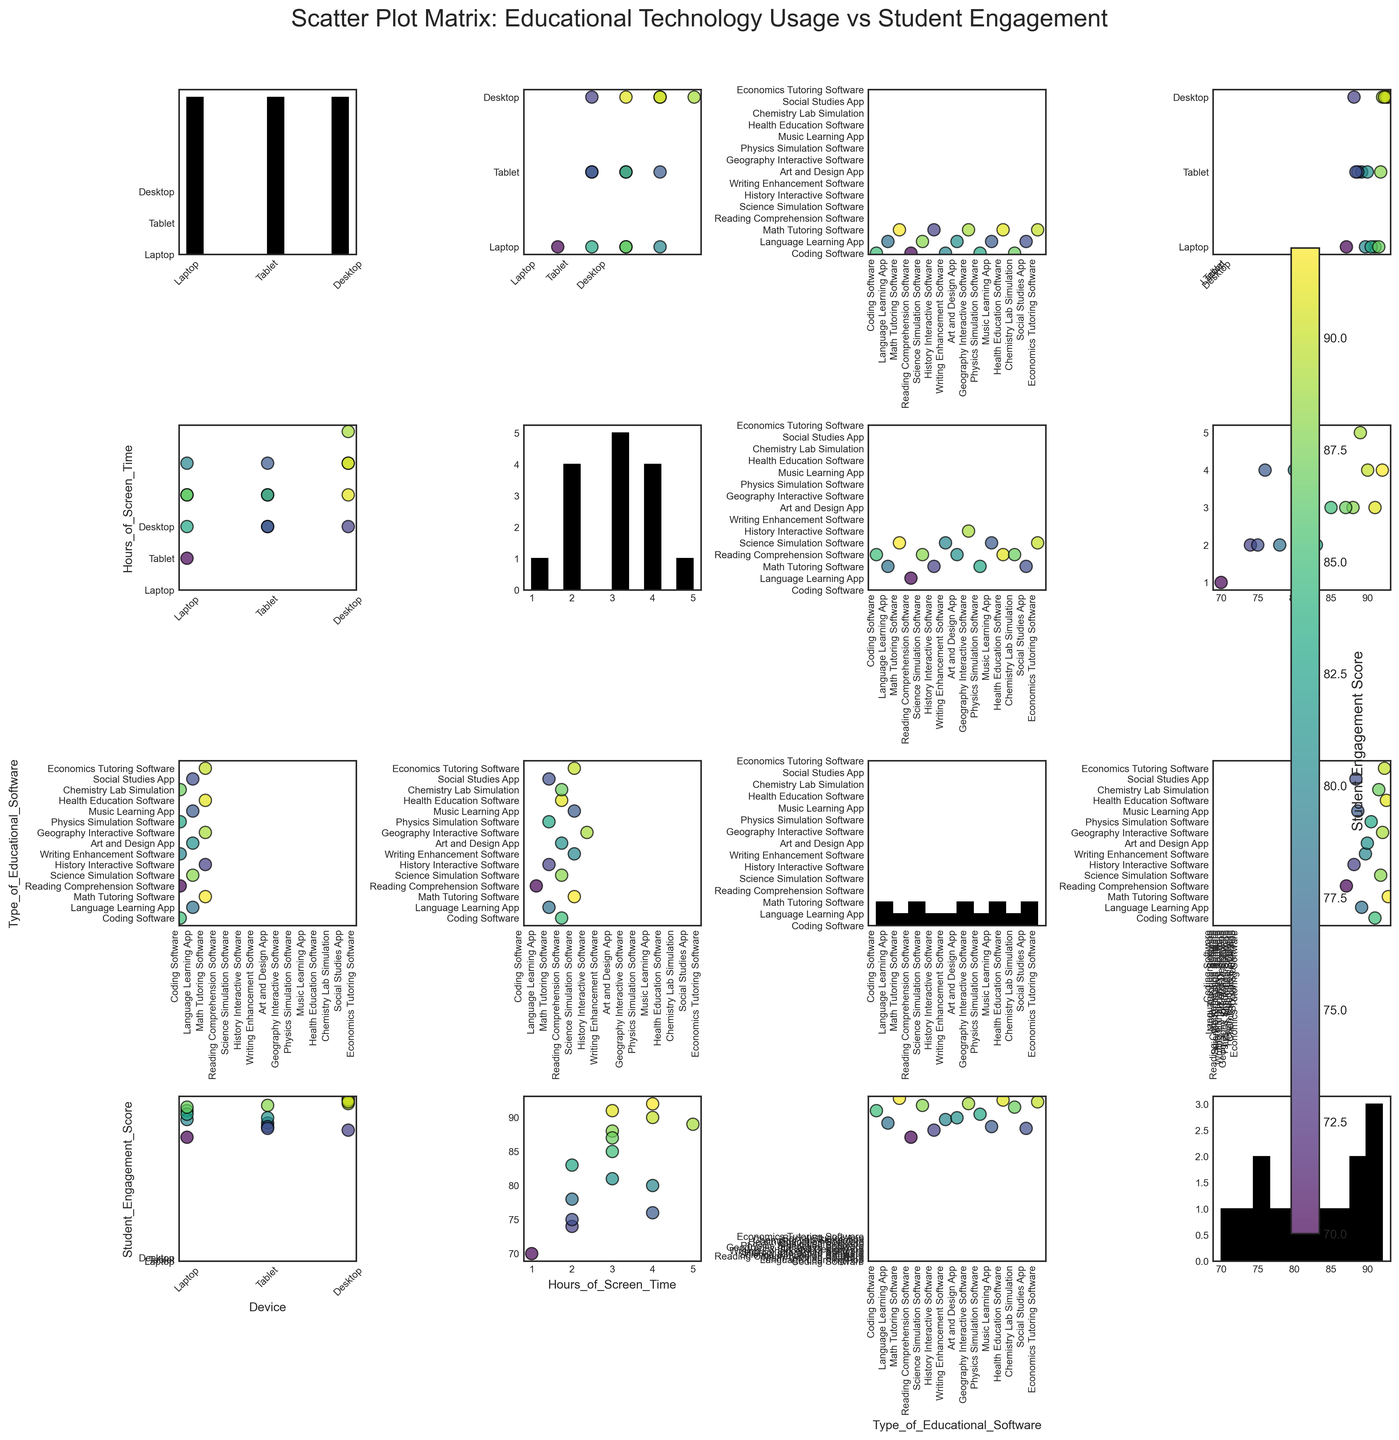How many different types of devices are represented in the scatter plot matrix? To determine the number of different devices, look at the unique tick labels on the 'Device' axis. You will see 'Laptop', 'Tablet', and 'Desktop', indicating three different types of devices.
Answer: 3 What is the most frequently used educational software type according to the histogram? Look at the histogram for 'Type_of_Educational_Software'. The bar with the greatest height represents the most frequently used type of educational software.
Answer: Coding Software Do students using tablets have higher or lower engagement scores compared to those using laptops based on the scatter plot? To answer this, compare the scatter points corresponding to 'Tablet' and 'Laptop' on the 'Student_Engagement_Score' axis. Note the general distribution and average of scores. Tablets seem to have slightly lower engagement scores compared to laptops.
Answer: Lower Which device type shows the highest student engagement score according to the scatter plot matrix? Look at the scatter plots where 'Device' is one of the axes and find the highest value on the 'Student_Engagement_Score' axis linked to a specific device type. 'Desktop' has the highest engagement score, reaching 92.
Answer: Desktop Is there a correlation between hours of screen time and student engagement scores? Examine the scatter plot where the x-axis is 'Hours_of_Screen_Time' and the y-axis is 'Student_Engagement_Score'. Observe the distribution pattern to assess correlation. The points display a general upward trend, indicating a positive correlation.
Answer: Positive correlation Which software type is associated with the highest student engagement score? Identify the scatter point with the highest value on the 'Student_Engagement_Score' axis in the scatter plots involving 'Type_of_Educational_Software'. 'Math Tutoring Software' has the highest engagement score of 92.
Answer: Math Tutoring Software What is the average student engagement score for laptops? Locate scatter points for 'Laptop' on the 'Device' axis and note their corresponding 'Student_Engagement_Score'. Calculate the average of these scores. The scores for laptops are 85, 70, 80, 83, and 87. Average = (85+70+80+83+87)/5 = 81
Answer: 81 Which device type has the most varied student engagement scores? Look at the spread of engagement scores for each device type across relevant scatter plots. 'Tablet' scores appear more clustered, while 'Desktop' and 'Laptop' show more variation. On further observation, 'Laptop' displays the widest range from 70 to 87.
Answer: Laptop 